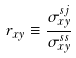Convert formula to latex. <formula><loc_0><loc_0><loc_500><loc_500>r _ { x y } \equiv \frac { \sigma ^ { s j } _ { x y } } { \sigma ^ { s s } _ { x y } }</formula> 